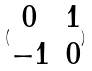Convert formula to latex. <formula><loc_0><loc_0><loc_500><loc_500>( \begin{matrix} 0 & 1 \\ - 1 & 0 \\ \end{matrix} )</formula> 